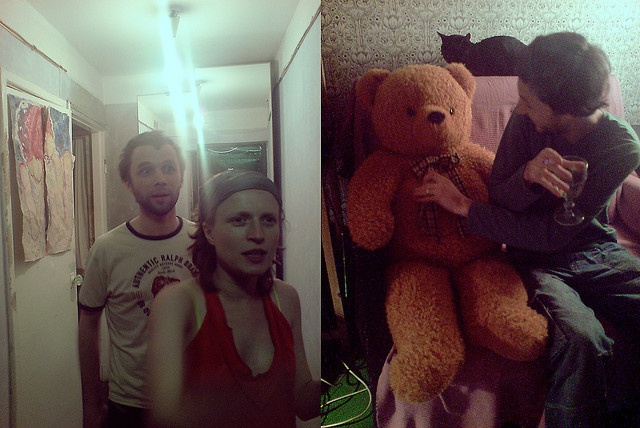Describe the objects in this image and their specific colors. I can see people in tan, black, gray, maroon, and purple tones, teddy bear in tan, maroon, black, and brown tones, people in tan, black, and gray tones, people in tan, gray, and black tones, and chair in tan, black, brown, and maroon tones in this image. 